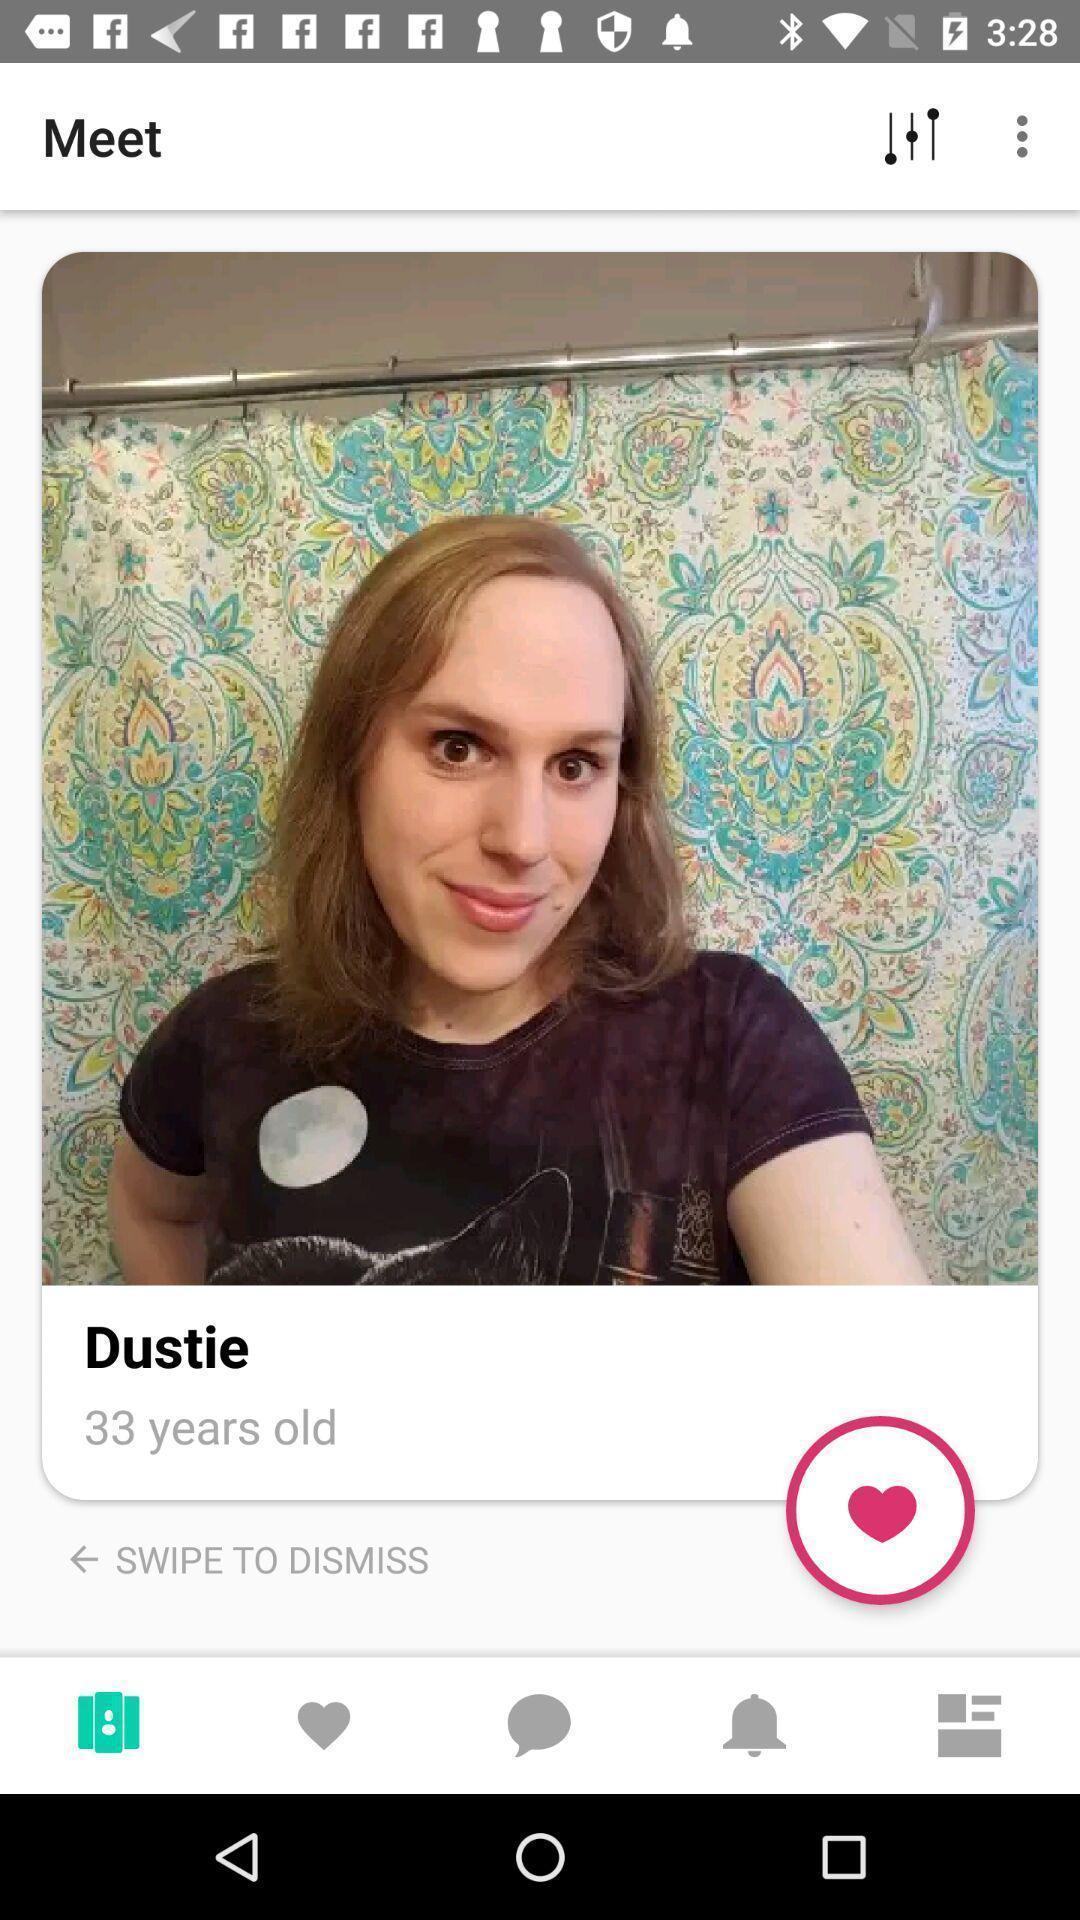What can you discern from this picture? Profile page. 